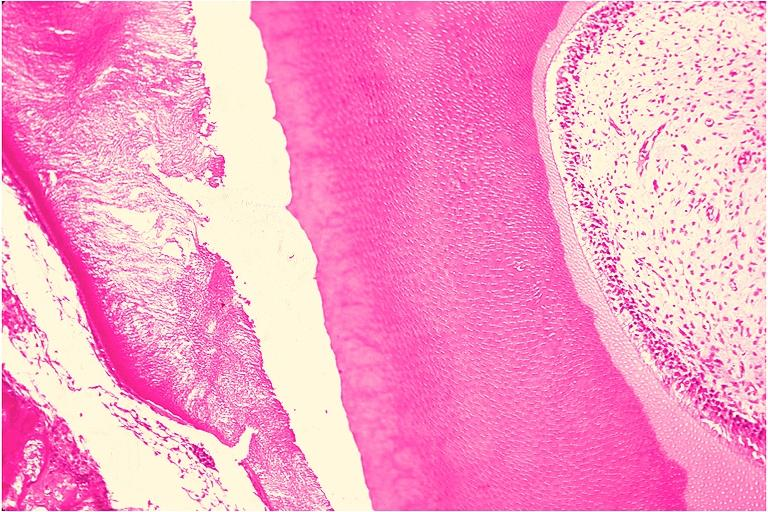does mucinous cystadenocarcinoma show odontoma?
Answer the question using a single word or phrase. No 